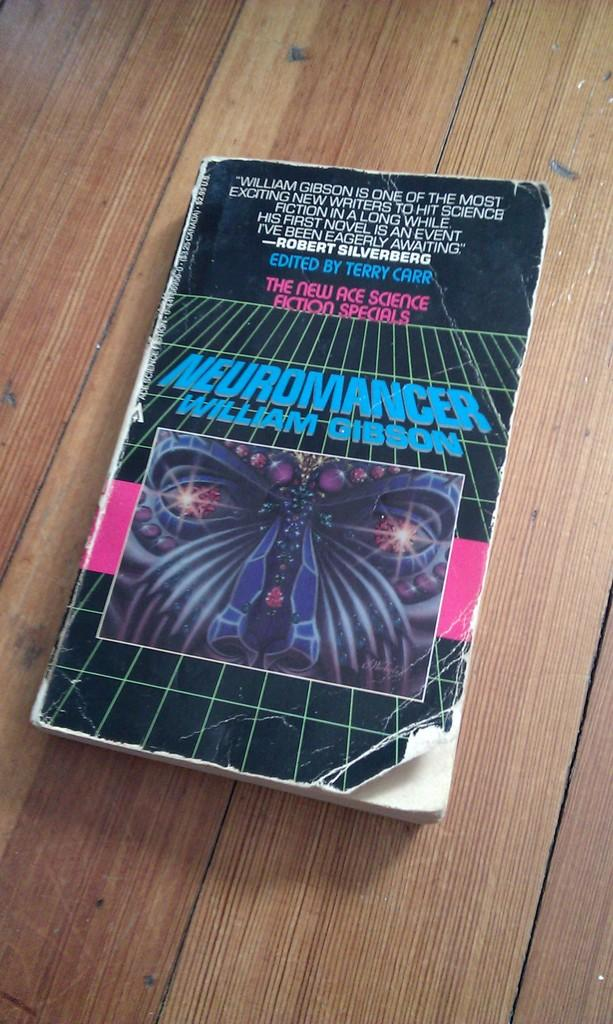<image>
Give a short and clear explanation of the subsequent image. A worn out paperback copy of Neuromancer by William Gibson 